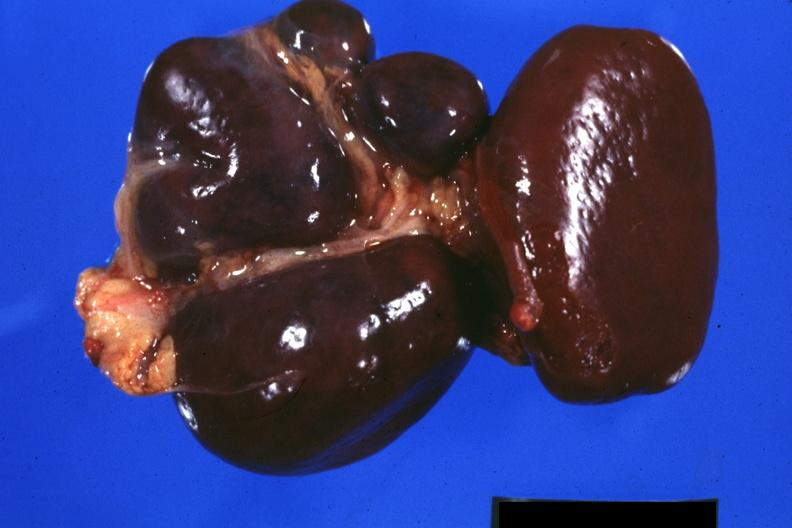s endometritis postpartum present?
Answer the question using a single word or phrase. No 